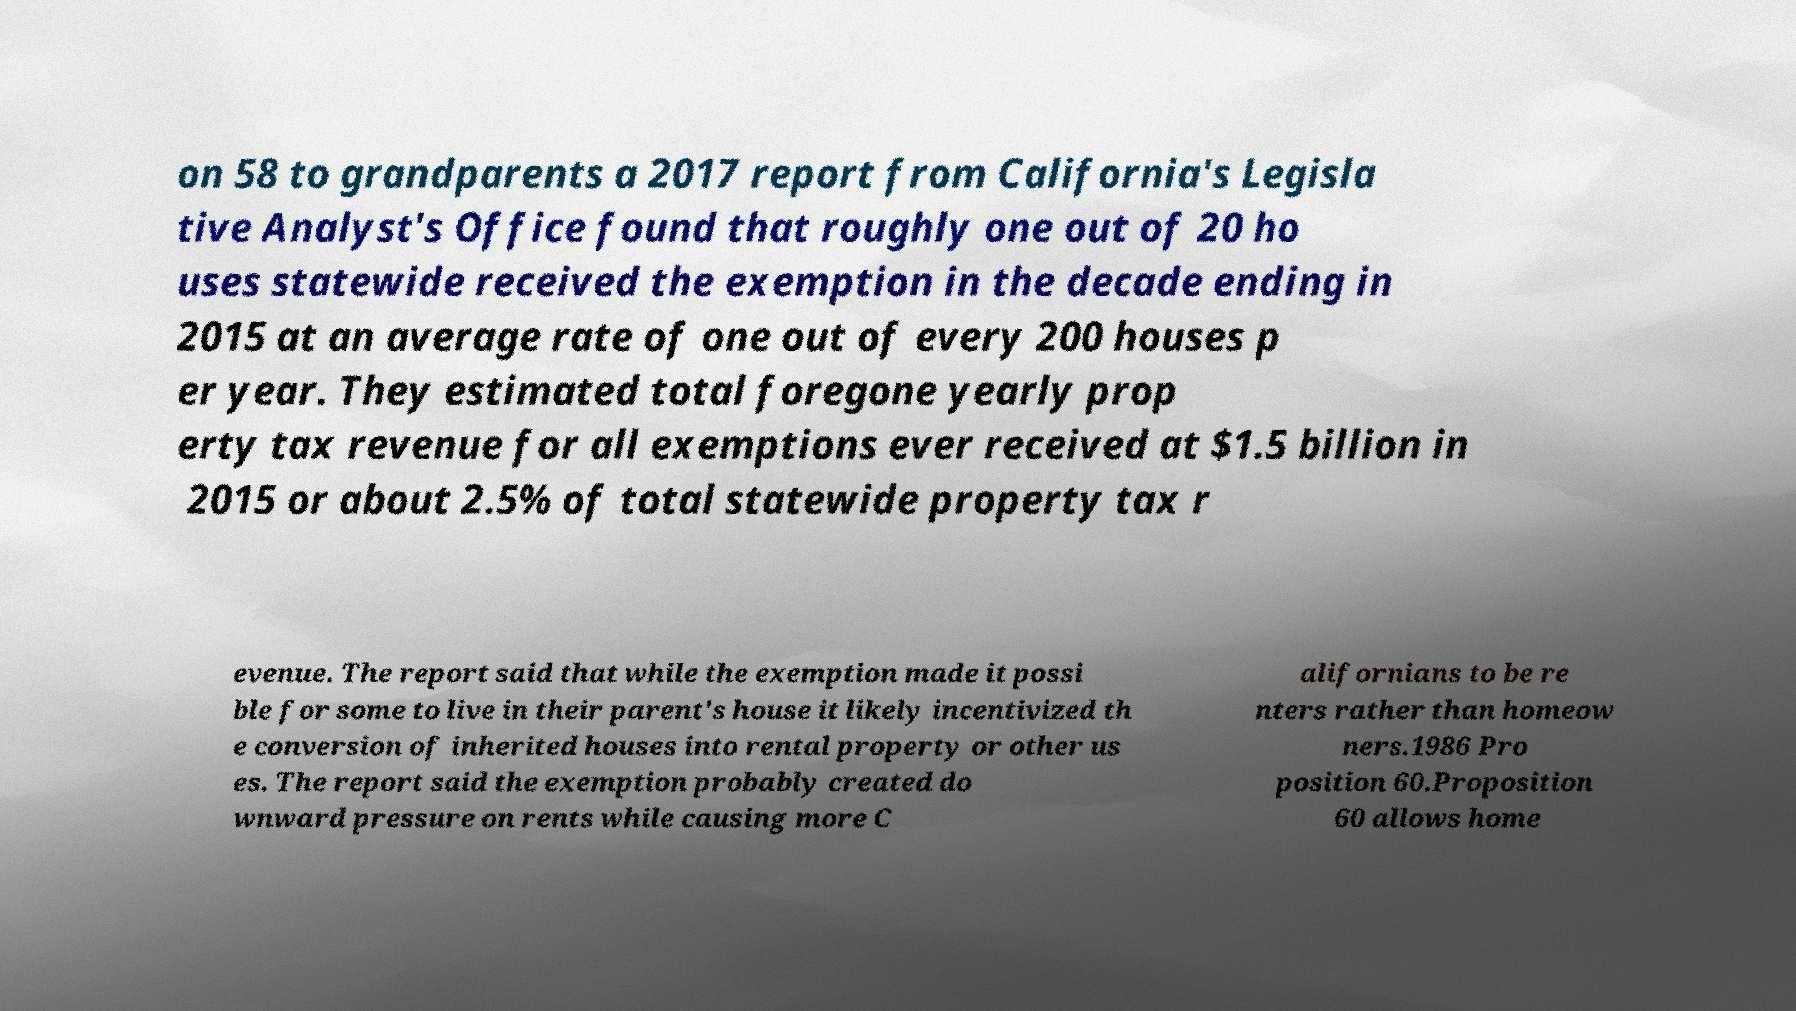For documentation purposes, I need the text within this image transcribed. Could you provide that? on 58 to grandparents a 2017 report from California's Legisla tive Analyst's Office found that roughly one out of 20 ho uses statewide received the exemption in the decade ending in 2015 at an average rate of one out of every 200 houses p er year. They estimated total foregone yearly prop erty tax revenue for all exemptions ever received at $1.5 billion in 2015 or about 2.5% of total statewide property tax r evenue. The report said that while the exemption made it possi ble for some to live in their parent's house it likely incentivized th e conversion of inherited houses into rental property or other us es. The report said the exemption probably created do wnward pressure on rents while causing more C alifornians to be re nters rather than homeow ners.1986 Pro position 60.Proposition 60 allows home 